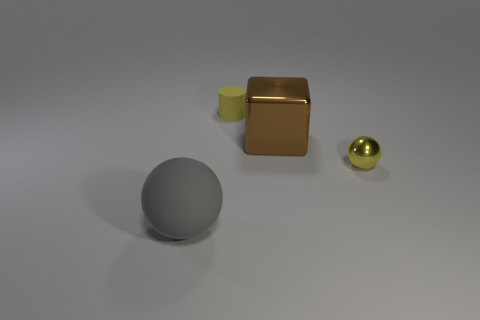What number of other things are there of the same shape as the gray rubber thing?
Give a very brief answer. 1. Is there a tiny sphere that has the same color as the small cylinder?
Keep it short and to the point. Yes. How many other spheres have the same size as the gray ball?
Your answer should be very brief. 0. There is a shiny thing that is on the right side of the big thing that is behind the rubber sphere; what is its color?
Offer a terse response. Yellow. Are there any gray matte cubes?
Your answer should be very brief. No. Does the big gray rubber thing have the same shape as the tiny yellow shiny thing?
Offer a very short reply. Yes. What is the size of the other object that is the same color as the small matte object?
Give a very brief answer. Small. There is a small thing in front of the big brown shiny object; what number of yellow cylinders are to the right of it?
Your answer should be compact. 0. How many things are both left of the tiny yellow shiny thing and behind the gray matte ball?
Provide a short and direct response. 2. How many objects are either shiny things or small things that are right of the small cylinder?
Give a very brief answer. 2. 